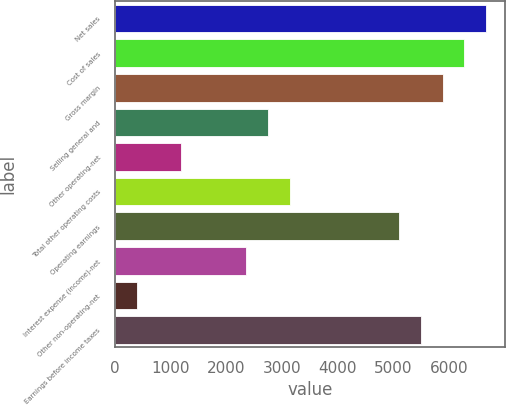Convert chart to OTSL. <chart><loc_0><loc_0><loc_500><loc_500><bar_chart><fcel>Net sales<fcel>Cost of sales<fcel>Gross margin<fcel>Selling general and<fcel>Other operating-net<fcel>Total other operating costs<fcel>Operating earnings<fcel>Interest expense (income)-net<fcel>Other non-operating-net<fcel>Earnings before income taxes<nl><fcel>6665.59<fcel>6273.52<fcel>5881.45<fcel>2744.89<fcel>1176.61<fcel>3136.96<fcel>5097.31<fcel>2352.82<fcel>392.47<fcel>5489.38<nl></chart> 